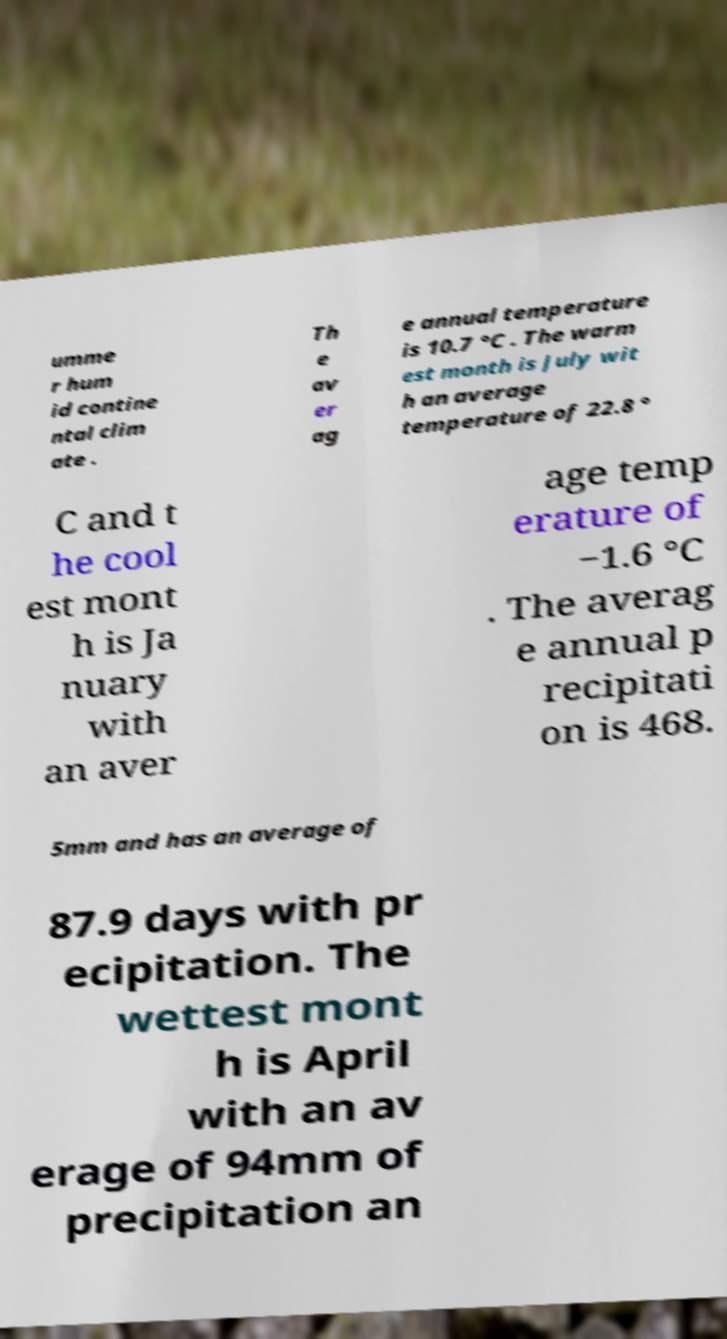Please read and relay the text visible in this image. What does it say? umme r hum id contine ntal clim ate . Th e av er ag e annual temperature is 10.7 °C . The warm est month is July wit h an average temperature of 22.8 ° C and t he cool est mont h is Ja nuary with an aver age temp erature of −1.6 °C . The averag e annual p recipitati on is 468. 5mm and has an average of 87.9 days with pr ecipitation. The wettest mont h is April with an av erage of 94mm of precipitation an 